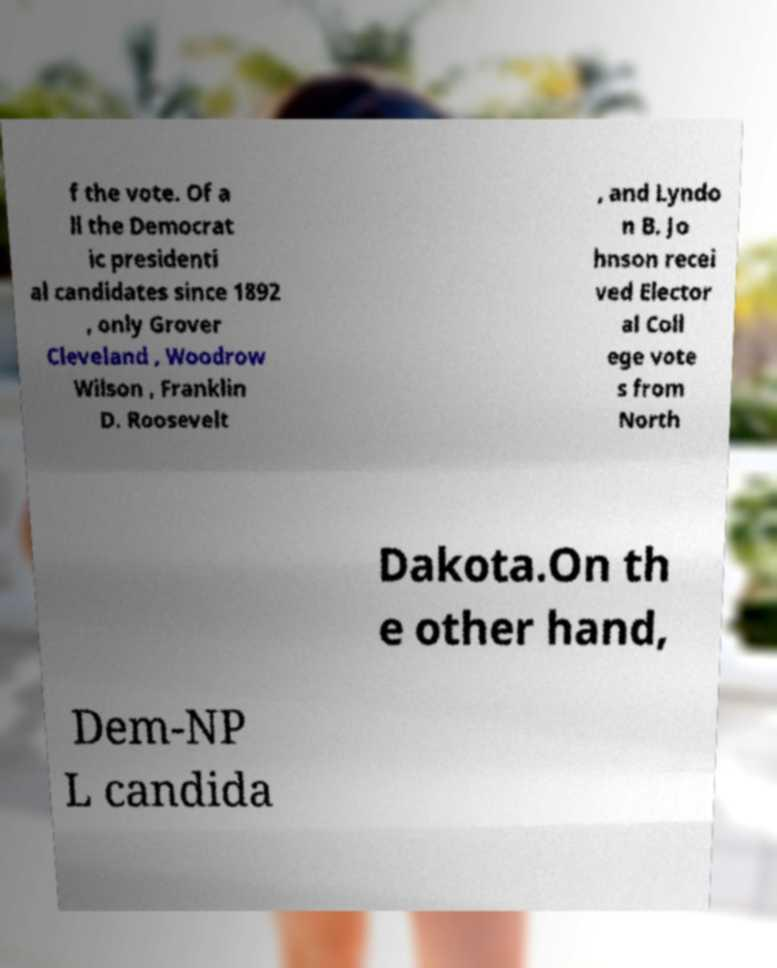Can you read and provide the text displayed in the image?This photo seems to have some interesting text. Can you extract and type it out for me? f the vote. Of a ll the Democrat ic presidenti al candidates since 1892 , only Grover Cleveland , Woodrow Wilson , Franklin D. Roosevelt , and Lyndo n B. Jo hnson recei ved Elector al Coll ege vote s from North Dakota.On th e other hand, Dem-NP L candida 